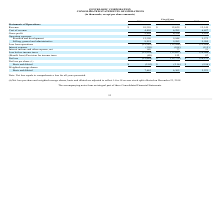From Quicklogic Corporation's financial document, What are the respective revenue in 2018 and 2019? The document shows two values: $12,629 and $10,310 (in thousands). From the document: "Revenue $ 10,310 $ 12,629 $ 12,149 Revenue $ 10,310 $ 12,629 $ 12,149..." Also, What are the respective cost of revenue in 2018 and 2019? The document shows two values: 6,295 and 4,405 (in thousands). From the document: "Cost of revenue 4,405 6,295 6,627 Cost of revenue 4,405 6,295 6,627..." Also, What are the respective gross profit in 2018 and 2019? The document shows two values: 6,334 and 5,905 (in thousands). From the document: "Gross profit 5,905 6,334 5,522 Gross profit 5,905 6,334 5,522..." Also, can you calculate: What is the percentage change in revenue between 2018 and 2019? To answer this question, I need to perform calculations using the financial data. The calculation is: (10,310 - 12,629)/12,629 , which equals -18.36 (percentage). This is based on the information: "Revenue $ 10,310 $ 12,629 $ 12,149 Revenue $ 10,310 $ 12,629 $ 12,149..." The key data points involved are: 10,310, 12,629. Also, can you calculate: What is the percentage change in cost of revenue between 2018 and 2019? To answer this question, I need to perform calculations using the financial data. The calculation is: (4,405 - 6,295)/6,295 , which equals -30.02 (percentage). This is based on the information: "Cost of revenue 4,405 6,295 6,627 Cost of revenue 4,405 6,295 6,627..." The key data points involved are: 4,405, 6,295. Also, can you calculate: What is the percentage change in gross profit between 2018 and 2019? To answer this question, I need to perform calculations using the financial data. The calculation is: (5,905 - 6,334)/6,334 , which equals -6.77 (percentage). This is based on the information: "Gross profit 5,905 6,334 5,522 Gross profit 5,905 6,334 5,522..." The key data points involved are: 5,905, 6,334. 